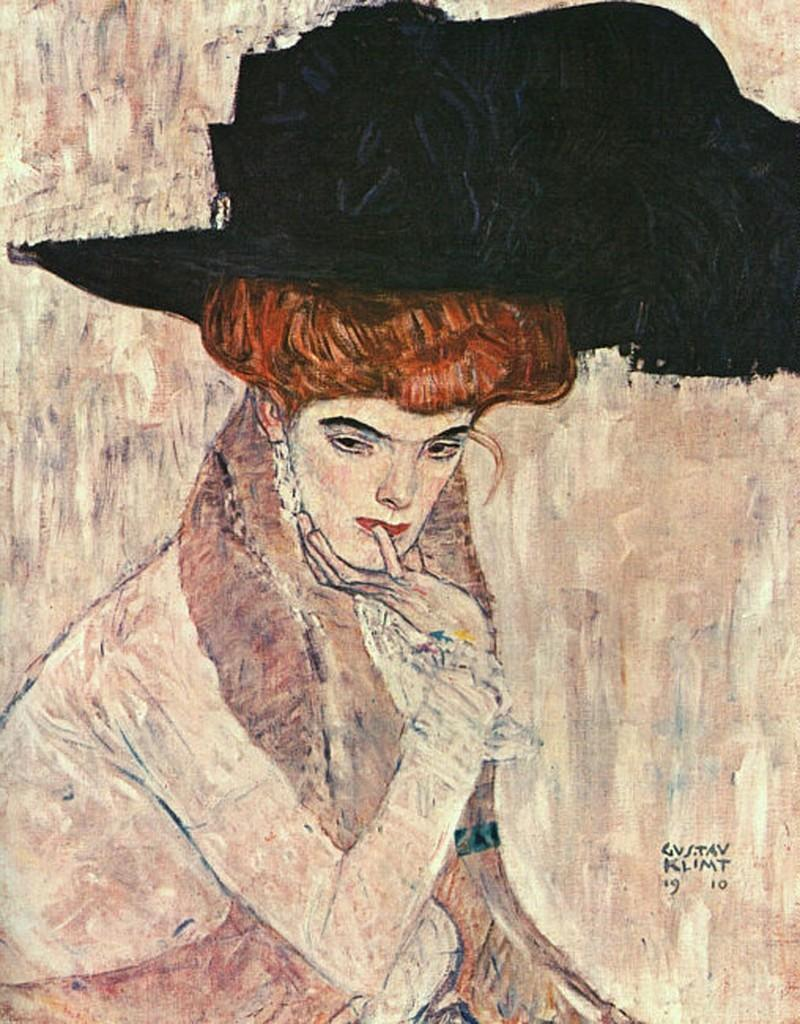What type of artwork is shown in the image? The image is a painting. Can you describe the subject matter of the painting? There is a person depicted in the painting. What type of disease is affecting the ground in the painting? There is no mention of a disease or ground in the painting; it only depicts a person. 